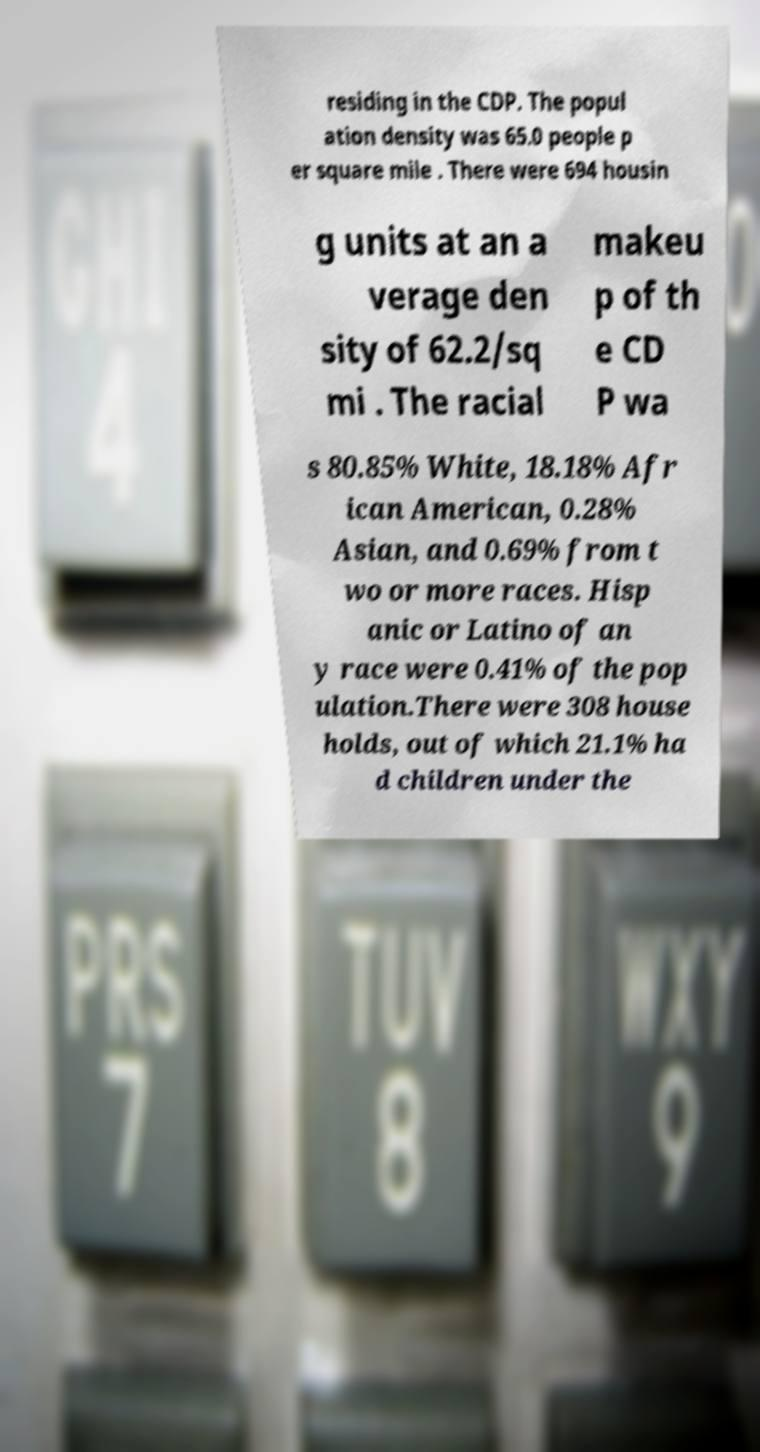What messages or text are displayed in this image? I need them in a readable, typed format. residing in the CDP. The popul ation density was 65.0 people p er square mile . There were 694 housin g units at an a verage den sity of 62.2/sq mi . The racial makeu p of th e CD P wa s 80.85% White, 18.18% Afr ican American, 0.28% Asian, and 0.69% from t wo or more races. Hisp anic or Latino of an y race were 0.41% of the pop ulation.There were 308 house holds, out of which 21.1% ha d children under the 